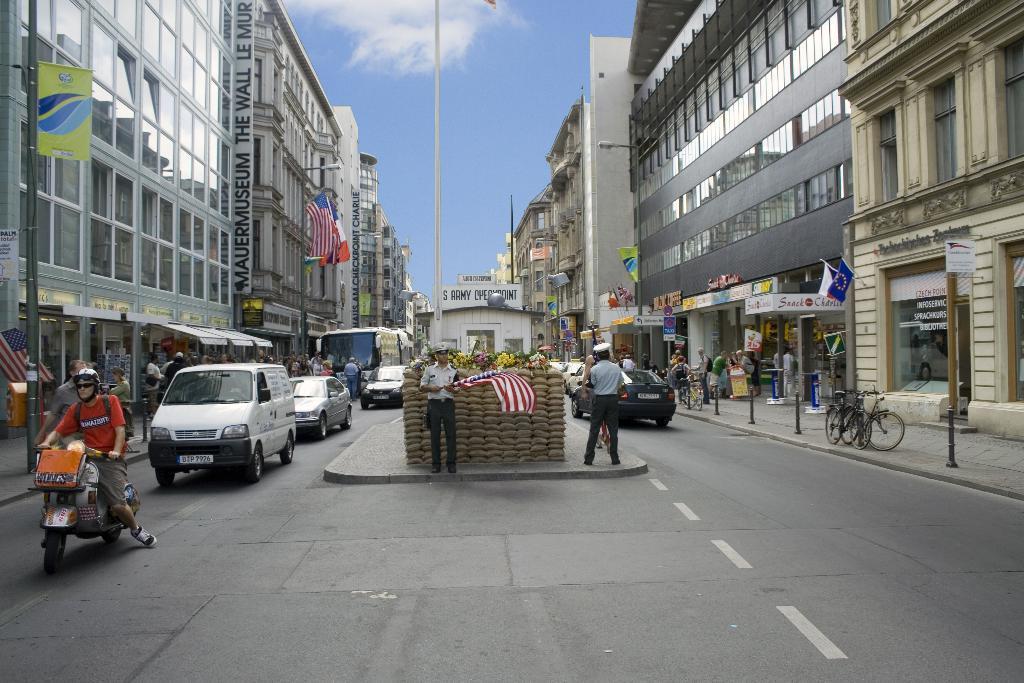In one or two sentences, can you explain what this image depicts? In this image I can see the road, few vehicles on the road, the sidewalk, few bicycles on the sidewalk and few persons standing on the sidewalk. I can see few poles, few flags, few buildings on both sides of the road and few plants in the middle of the road. In the background I can see the sky. 